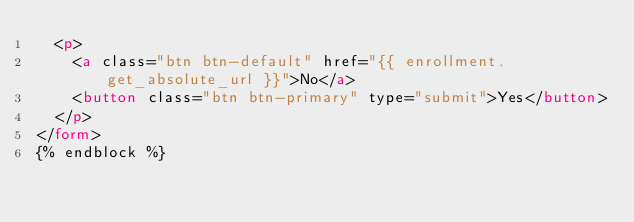Convert code to text. <code><loc_0><loc_0><loc_500><loc_500><_HTML_>  <p>
    <a class="btn btn-default" href="{{ enrollment.get_absolute_url }}">No</a>
    <button class="btn btn-primary" type="submit">Yes</button>
  </p>
</form>
{% endblock %}
</code> 